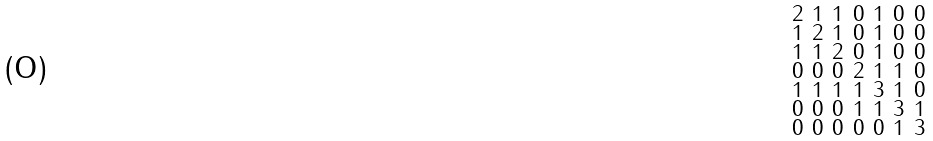Convert formula to latex. <formula><loc_0><loc_0><loc_500><loc_500>\begin{smallmatrix} 2 & 1 & 1 & 0 & 1 & 0 & 0 \\ 1 & 2 & 1 & 0 & 1 & 0 & 0 \\ 1 & 1 & 2 & 0 & 1 & 0 & 0 \\ 0 & 0 & 0 & 2 & 1 & 1 & 0 \\ 1 & 1 & 1 & 1 & 3 & 1 & 0 \\ 0 & 0 & 0 & 1 & 1 & 3 & 1 \\ 0 & 0 & 0 & 0 & 0 & 1 & 3 \end{smallmatrix}</formula> 